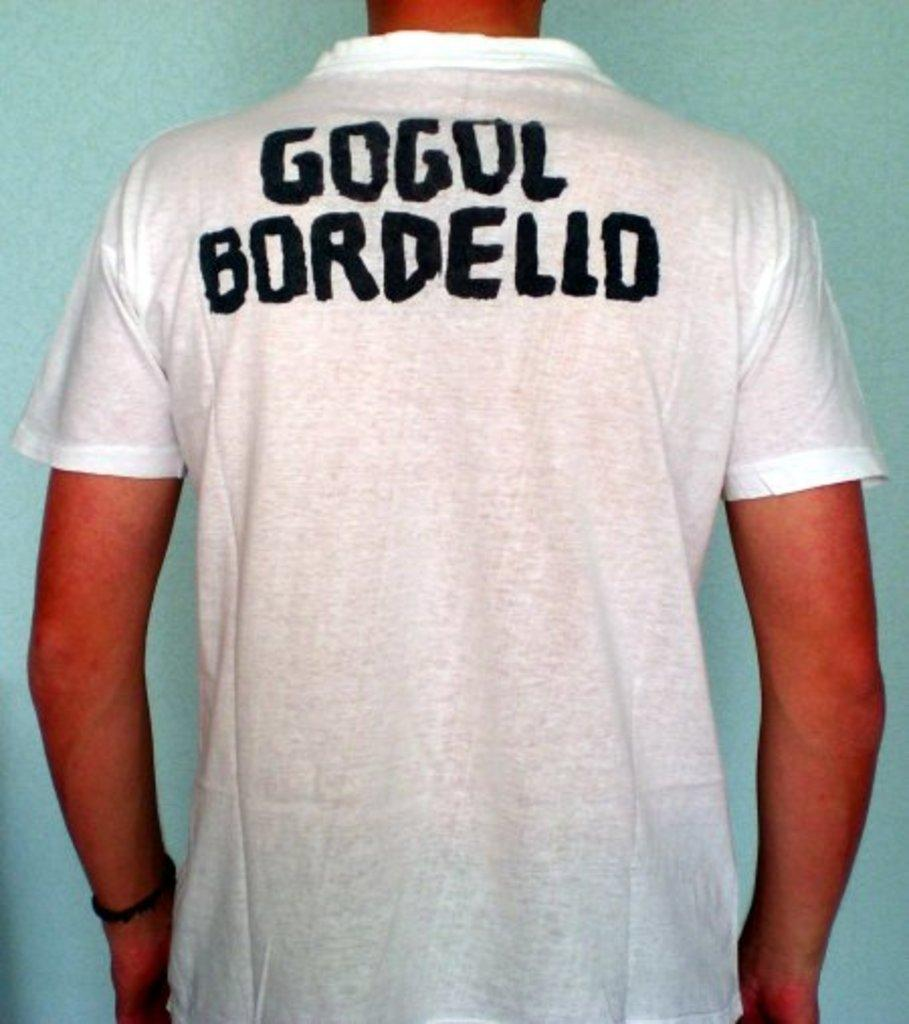<image>
Share a concise interpretation of the image provided. a shirt that says gogul on the back of it 